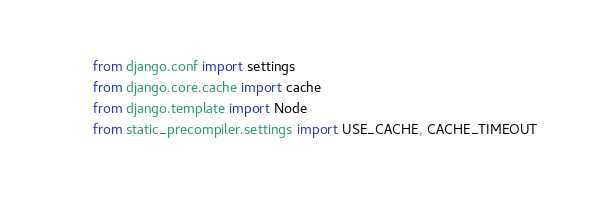<code> <loc_0><loc_0><loc_500><loc_500><_Python_>from django.conf import settings
from django.core.cache import cache
from django.template import Node
from static_precompiler.settings import USE_CACHE, CACHE_TIMEOUT</code> 